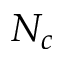<formula> <loc_0><loc_0><loc_500><loc_500>N _ { c }</formula> 